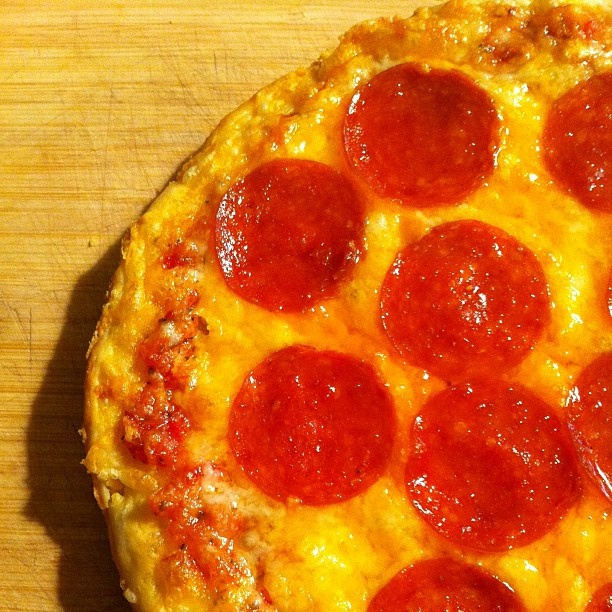Describe the objects in this image and their specific colors. I can see pizza in orange, red, and brown tones and dining table in orange, gold, and maroon tones in this image. 